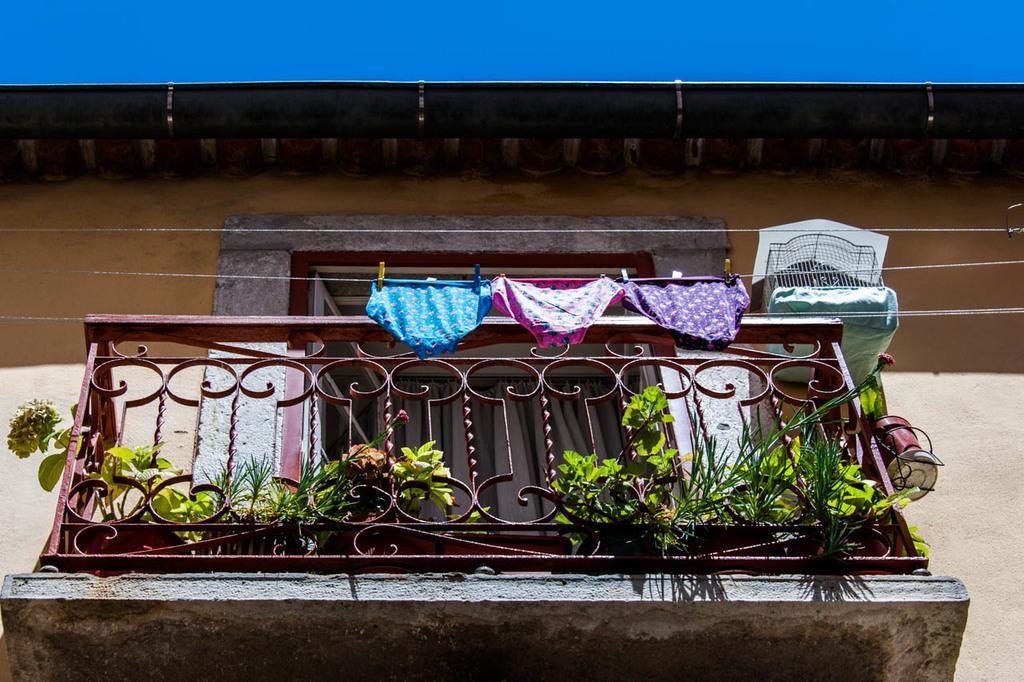Can you describe this image briefly? In this picture there is a balcony of a building which has a fence and few plants in front of it and there are few inner wear attached to the rope beside it. 